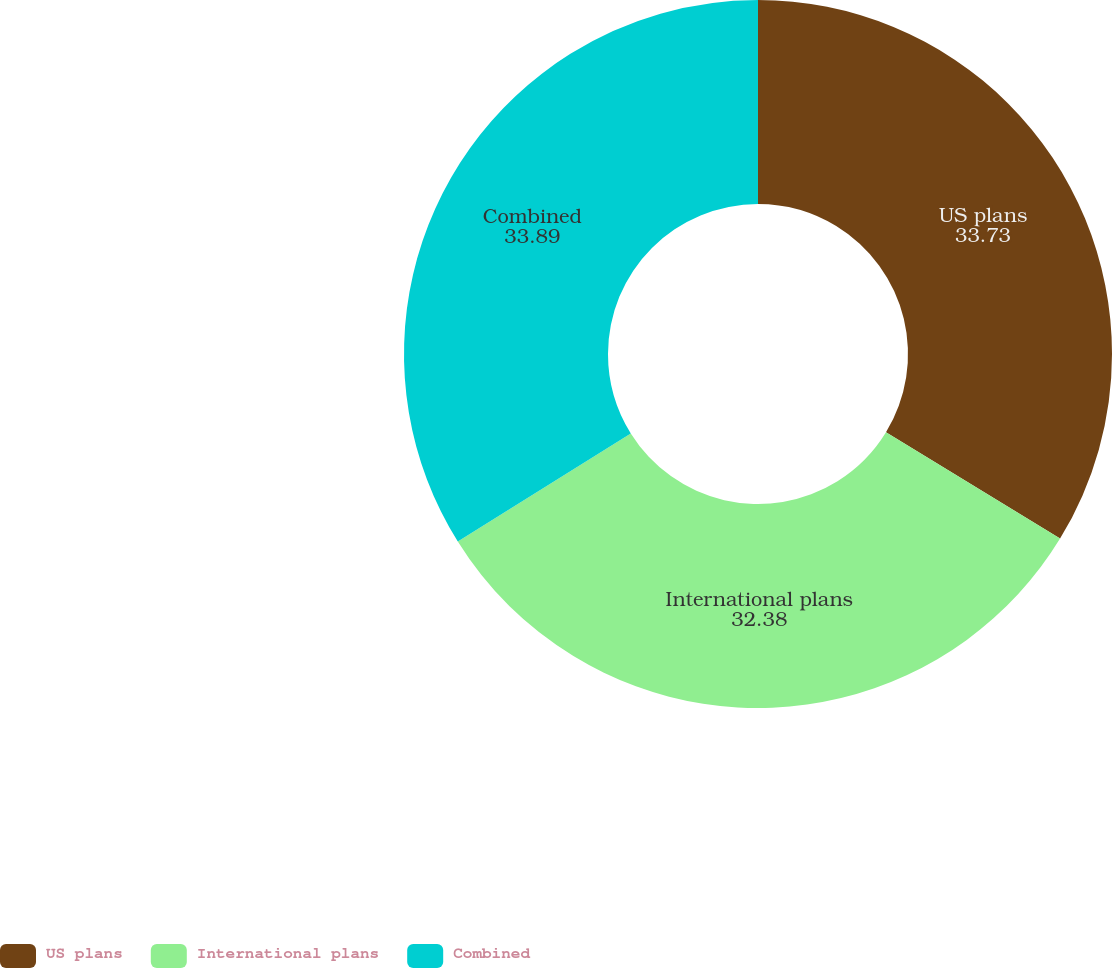Convert chart. <chart><loc_0><loc_0><loc_500><loc_500><pie_chart><fcel>US plans<fcel>International plans<fcel>Combined<nl><fcel>33.73%<fcel>32.38%<fcel>33.89%<nl></chart> 